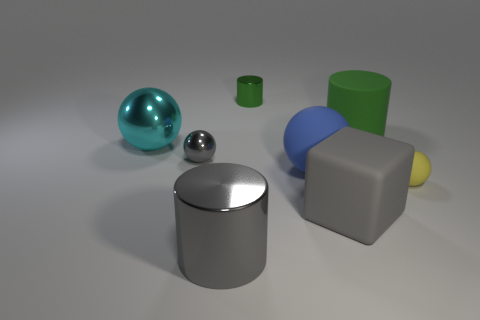Subtract all blue spheres. How many spheres are left? 3 Add 1 small red balls. How many objects exist? 9 Subtract all yellow cubes. How many green cylinders are left? 2 Subtract all green cylinders. How many cylinders are left? 1 Subtract 1 cylinders. How many cylinders are left? 2 Subtract all cubes. How many objects are left? 7 Add 7 small brown metal things. How many small brown metal things exist? 7 Subtract 0 red cubes. How many objects are left? 8 Subtract all brown spheres. Subtract all gray cylinders. How many spheres are left? 4 Subtract all small blue rubber cubes. Subtract all gray cylinders. How many objects are left? 7 